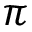Convert formula to latex. <formula><loc_0><loc_0><loc_500><loc_500>\pi</formula> 